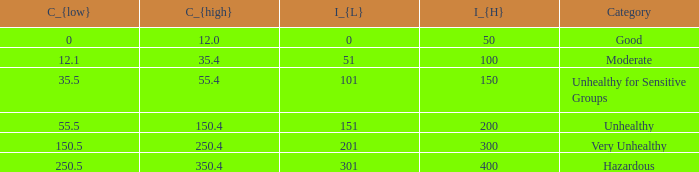Would you mind parsing the complete table? {'header': ['C_{low}', 'C_{high}', 'I_{L}', 'I_{H}', 'Category'], 'rows': [['0', '12.0', '0', '50', 'Good'], ['12.1', '35.4', '51', '100', 'Moderate'], ['35.5', '55.4', '101', '150', 'Unhealthy for Sensitive Groups'], ['55.5', '150.4', '151', '200', 'Unhealthy'], ['150.5', '250.4', '201', '300', 'Very Unhealthy'], ['250.5', '350.4', '301', '400', 'Hazardous']]} What's the i_{high} value when C_{low} is 250.5? 400.0. 